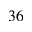Convert formula to latex. <formula><loc_0><loc_0><loc_500><loc_500>^ { 3 6 }</formula> 